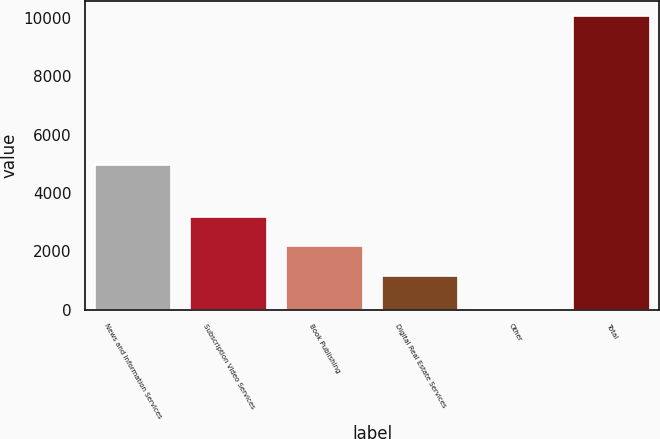Convert chart to OTSL. <chart><loc_0><loc_0><loc_500><loc_500><bar_chart><fcel>News and Information Services<fcel>Subscription Video Services<fcel>Book Publishing<fcel>Digital Real Estate Services<fcel>Other<fcel>Total<nl><fcel>4956<fcel>3173.2<fcel>2166.1<fcel>1159<fcel>3<fcel>10074<nl></chart> 